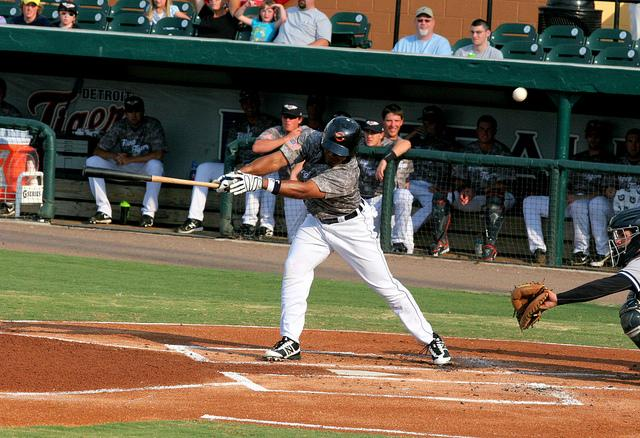What is the man with the bat about to do? Please explain your reasoning. swing. The man wants to swing his bat at the ball. 